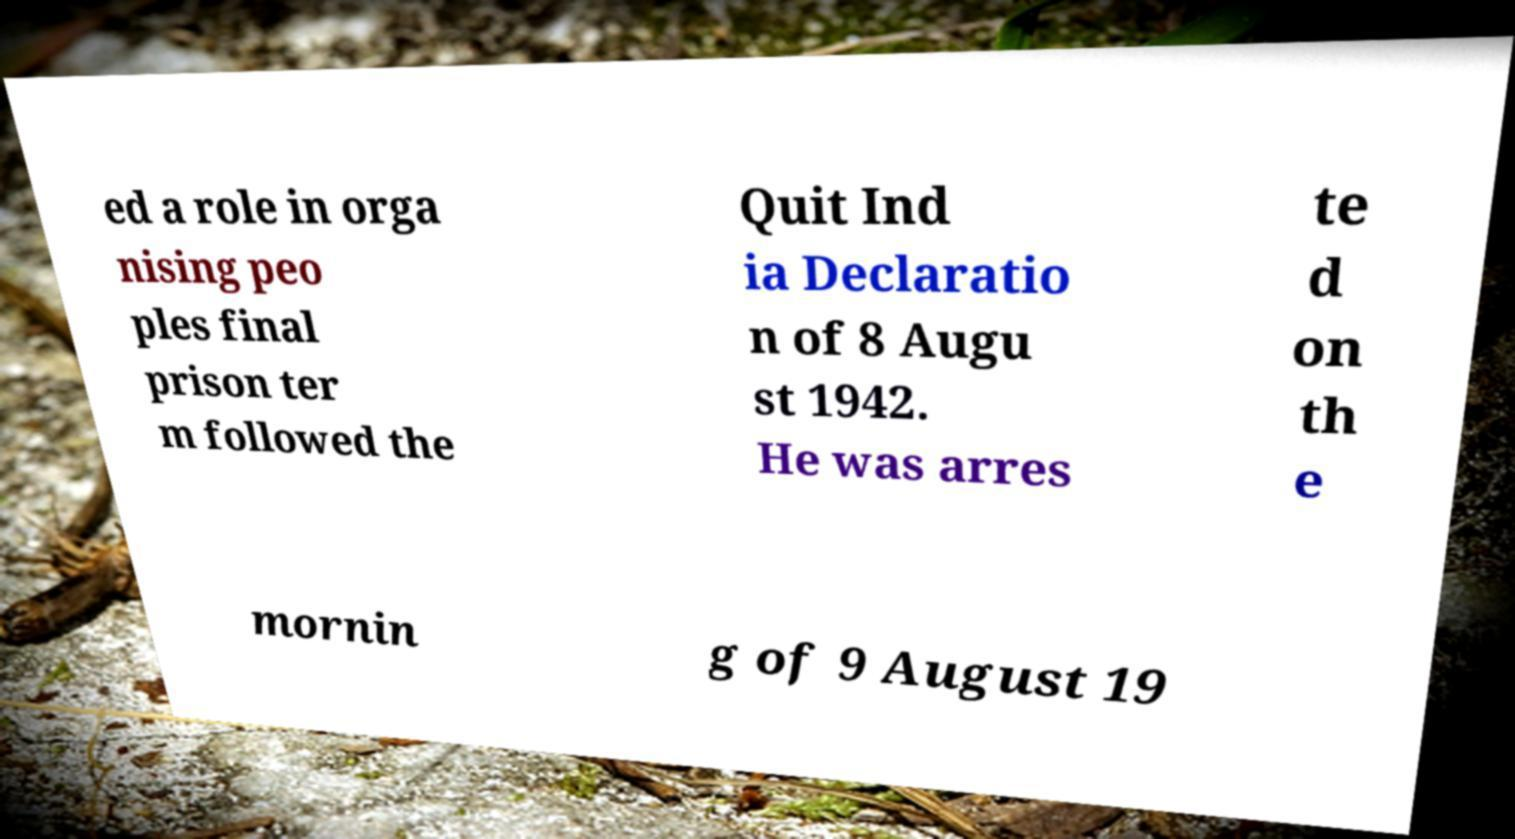There's text embedded in this image that I need extracted. Can you transcribe it verbatim? ed a role in orga nising peo ples final prison ter m followed the Quit Ind ia Declaratio n of 8 Augu st 1942. He was arres te d on th e mornin g of 9 August 19 